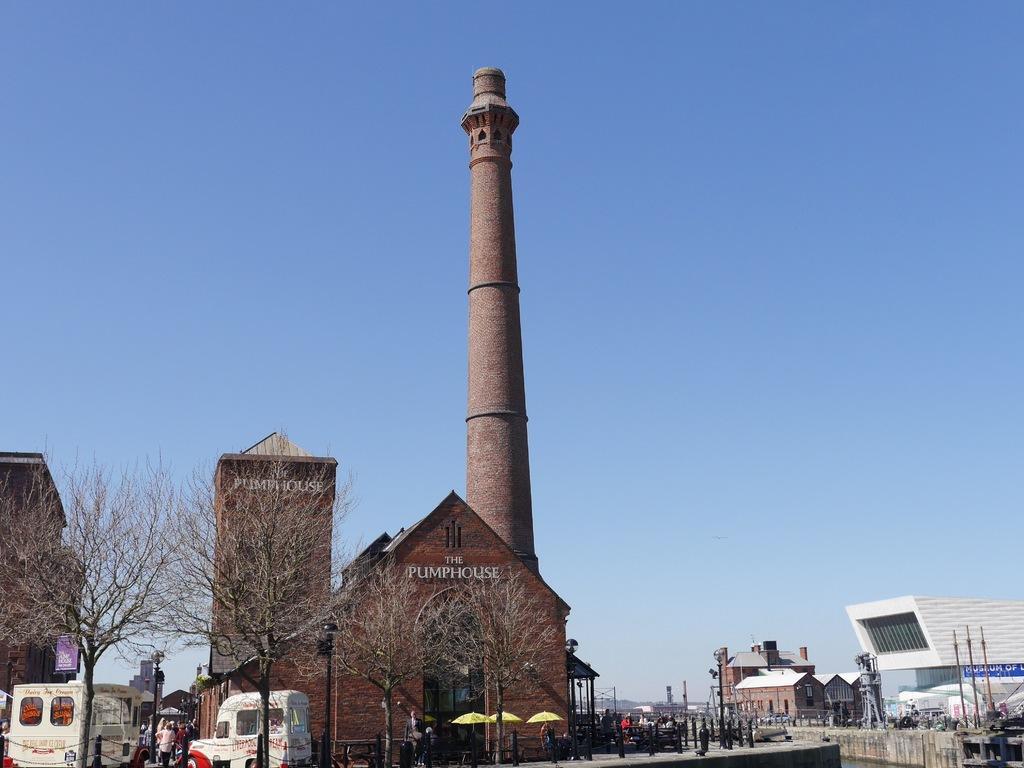Could you give a brief overview of what you see in this image? In this image we can see some houses, one building, one pond with water, one spire in the middle of the image, some small poles near the pond, some big poles, some boards with poles, some people are walking, some text on the houses, one blue banner with text, some vehicles on the road, some people are standing, some people are sitting, one object on the ground looks like a machine, some people are holding some objects, some objects on the ground, three yellow umbrellas, some trees on the ground and at the top there is the sky. 